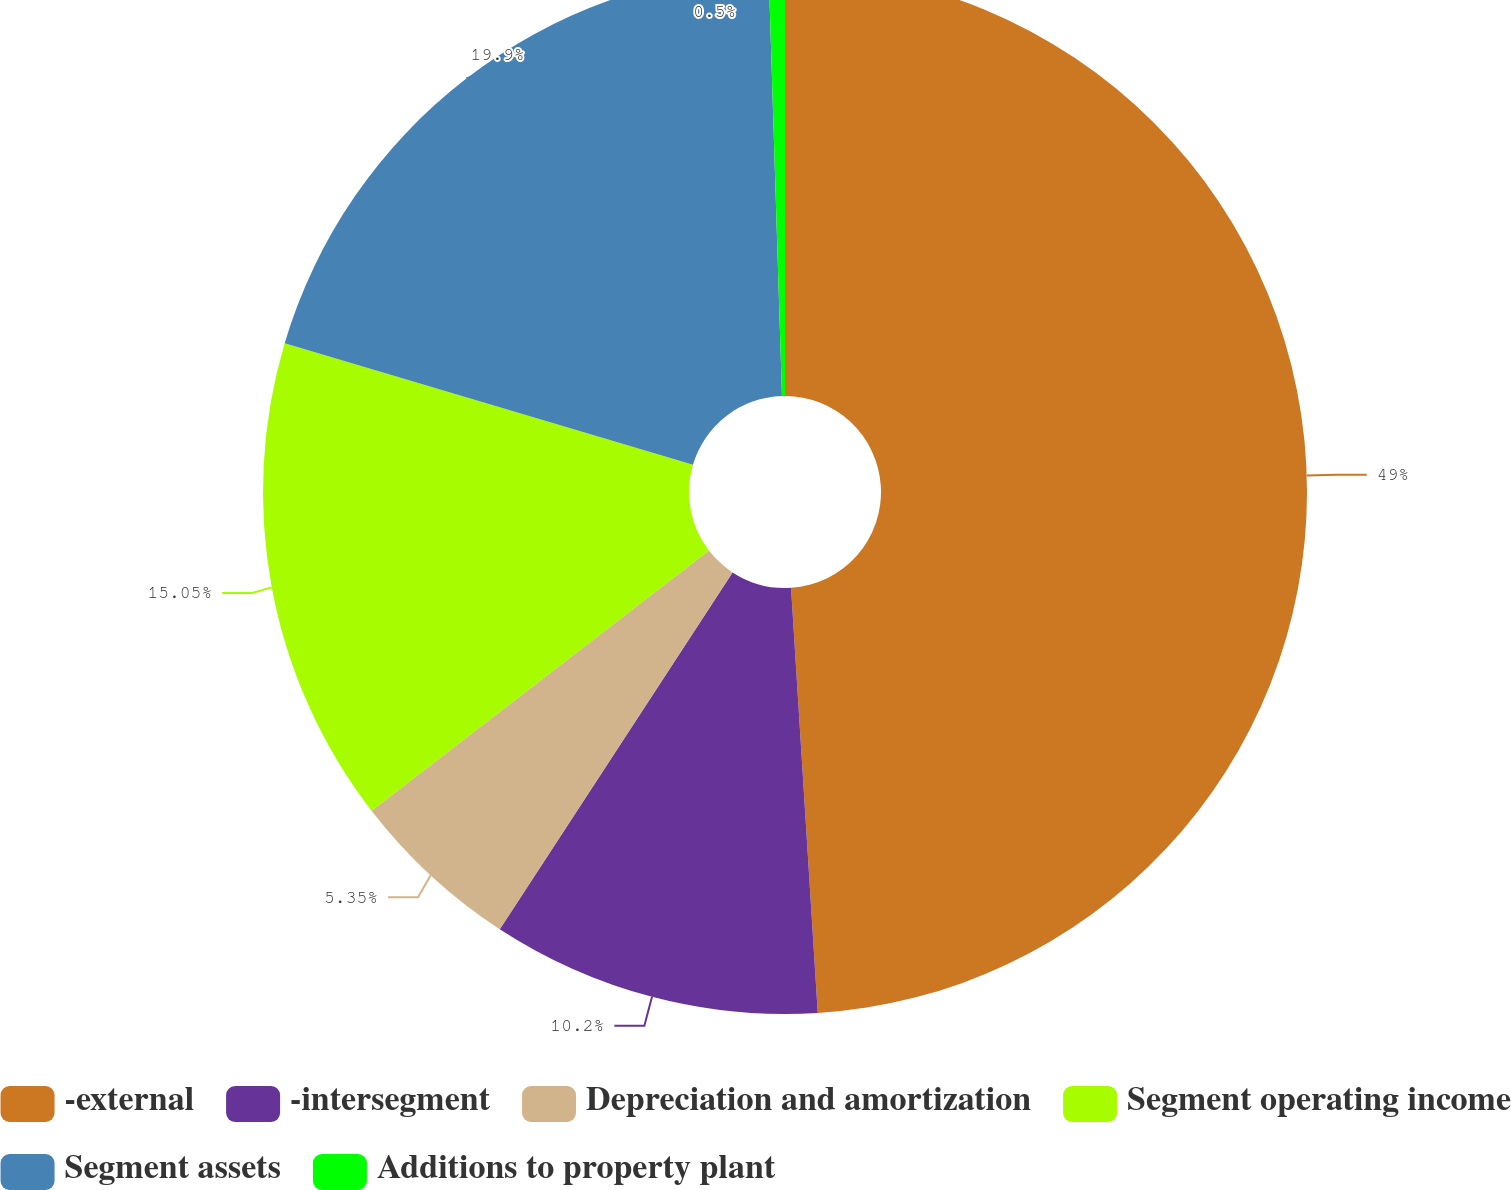Convert chart. <chart><loc_0><loc_0><loc_500><loc_500><pie_chart><fcel>-external<fcel>-intersegment<fcel>Depreciation and amortization<fcel>Segment operating income<fcel>Segment assets<fcel>Additions to property plant<nl><fcel>49.0%<fcel>10.2%<fcel>5.35%<fcel>15.05%<fcel>19.9%<fcel>0.5%<nl></chart> 